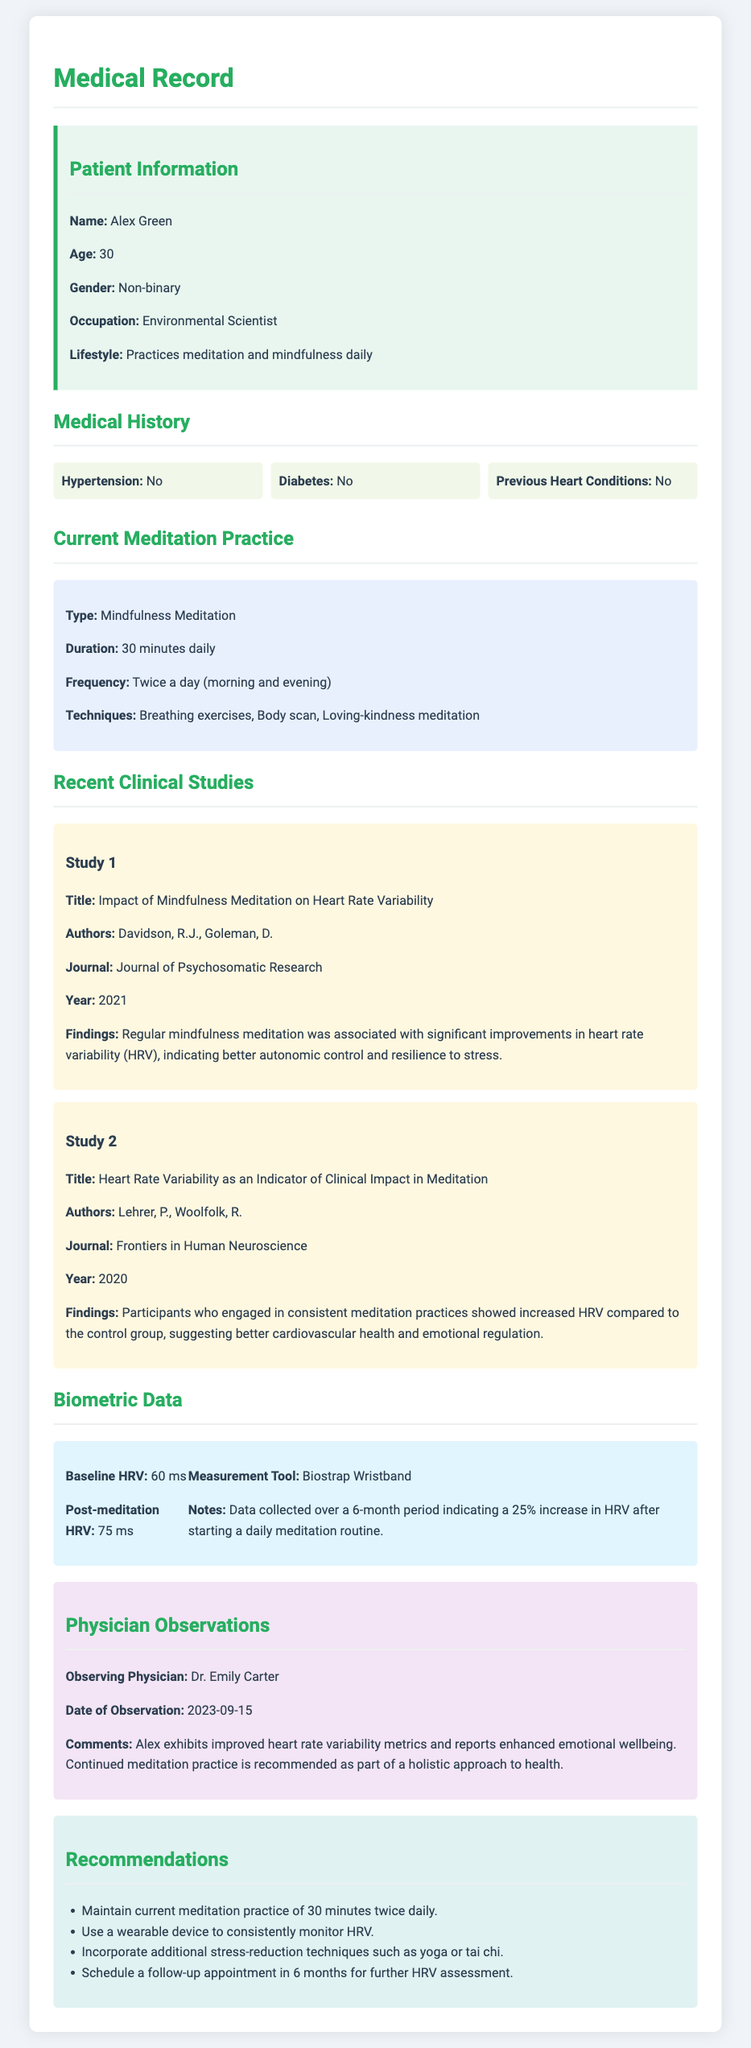What is the name of the patient? The document provides the patient's name at the top of the patient information section.
Answer: Alex Green What is the type of meditation practiced? The document specifies the type of meditation practiced by the patient in the current meditation practice section.
Answer: Mindfulness Meditation What is the frequency of the meditation sessions? The patient information section indicates how often the meditation sessions are conducted.
Answer: Twice a day What is the baseline heart rate variability (HRV)? The biometric data section lists the baseline HRV value.
Answer: 60 ms What was the increase in heart rate variability after meditation? The document includes a comparison of HRV before and after starting daily meditation in the biometric data section.
Answer: 25% Who is the observing physician? The physician's name is given in the physician observations section of the document.
Answer: Dr. Emily Carter What publication year is associated with the first study mentioned? The recent clinical studies section provides the year for the first study.
Answer: 2021 What is the recommended follow-up timeframe? Recommendations section indicates when the follow-up appointment should be scheduled.
Answer: 6 months 